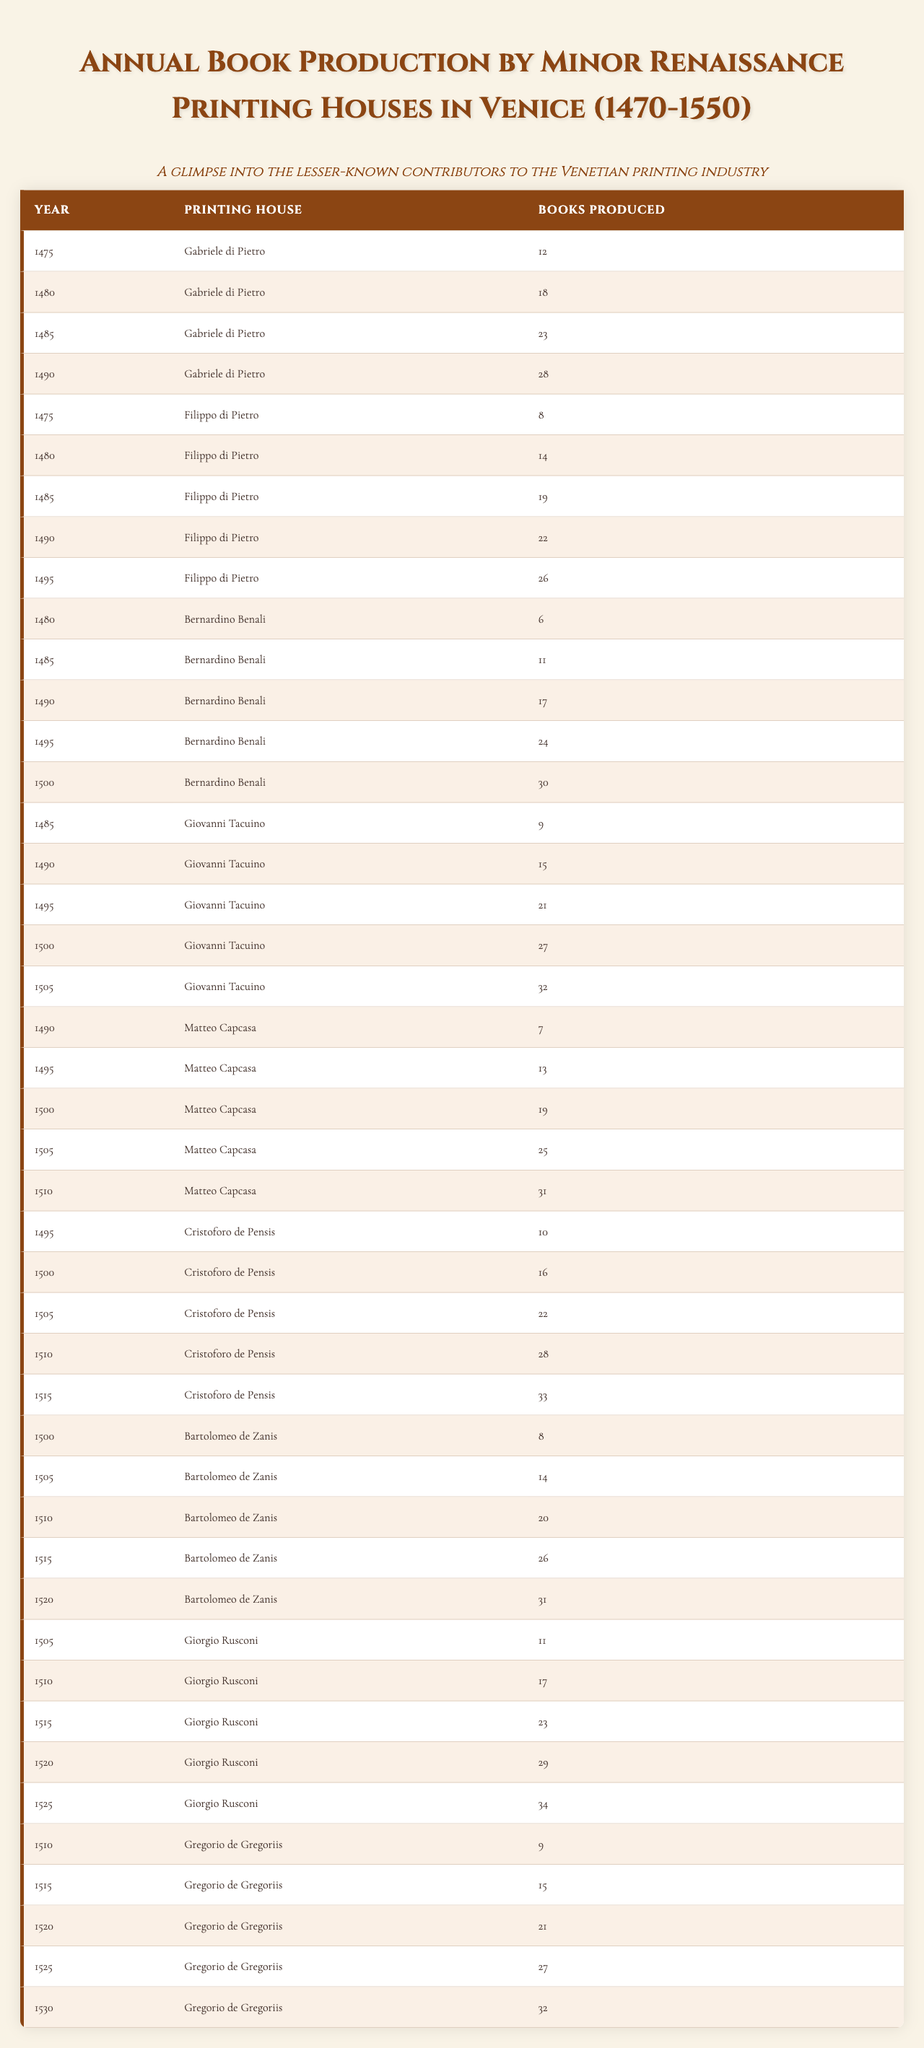What was the highest number of books produced by a single printing house in a single year? Looking at the table, the highest number of books produced by a single printing house in one year is 34, achieved by Giorgio Rusconi in 1525.
Answer: 34 In which year did Bernardino Benali produce the most books? According to the table, Bernardino Benali produced the most books in 1500, with a total of 30 books produced that year.
Answer: 30 How many books did Gabriele di Pietro produce from 1475 to 1490? Summing the values for Gabriele di Pietro from the years 1475 (12), 1480 (18), 1485 (23), and 1490 (28) gives 12 + 18 + 23 + 28 = 81.
Answer: 81 Which printing house produced the most books in 1515? According to the table, Cristoforo de Pensis produced the most books in 1515, with a total of 33 books.
Answer: Cristoforo de Pensis What is the average number of books produced by Matteo Capcasa over the years he was active? Matteo Capcasa produced books in 1490 (7), 1495 (13), 1500 (19), 1505 (25), and 1510 (31). Summing these gives 7 + 13 + 19 + 25 + 31 = 95, and with 5 years of data, the average is 95/5 = 19.
Answer: 19 Did any printing house outperform others consistently over the years? Analyzing the data, Giovanni Tacuino shows a steady increase, which culminates in 32 books in 1505. This consistent growth without declines could suggest his relative success.
Answer: Yes What was the total number of books produced by Bartolomeo de Zanis from 1500 to 1520? Bartolomeo de Zanis produced books in 1500 (8), 1505 (14), 1510 (20), 1515 (26), and 1520 (31). The total is 8 + 14 + 20 + 26 + 31 = 99.
Answer: 99 Is there a year where all printing houses produced more than 20 books? By examining the individual productions in the table, the year 1505 shows books produced by Giovanni Tacuino (32), Matteo Capcasa (25), Cristoforo de Pensis (22), and Bartolomeo de Zanis (14), only one house's total fell below 20. Hence, no such year meets all criteria.
Answer: No What was the trend in book production from 1475 to 1550 among minor printing houses in Venice? Observing the table, there is a noticeable upward trend in book production over the decades, particularly from the 1490s onwards, indicating growth in printing activities.
Answer: Upward trend Which printing house had the least total production over the years listed? By calculating total productions, Bernardino Benali has a total of 108 books in total. Comparatively, Gabriele di Pietro has a total of 81 (significantly lower), indicating he has the least total production overall.
Answer: Gabriele di Pietro 